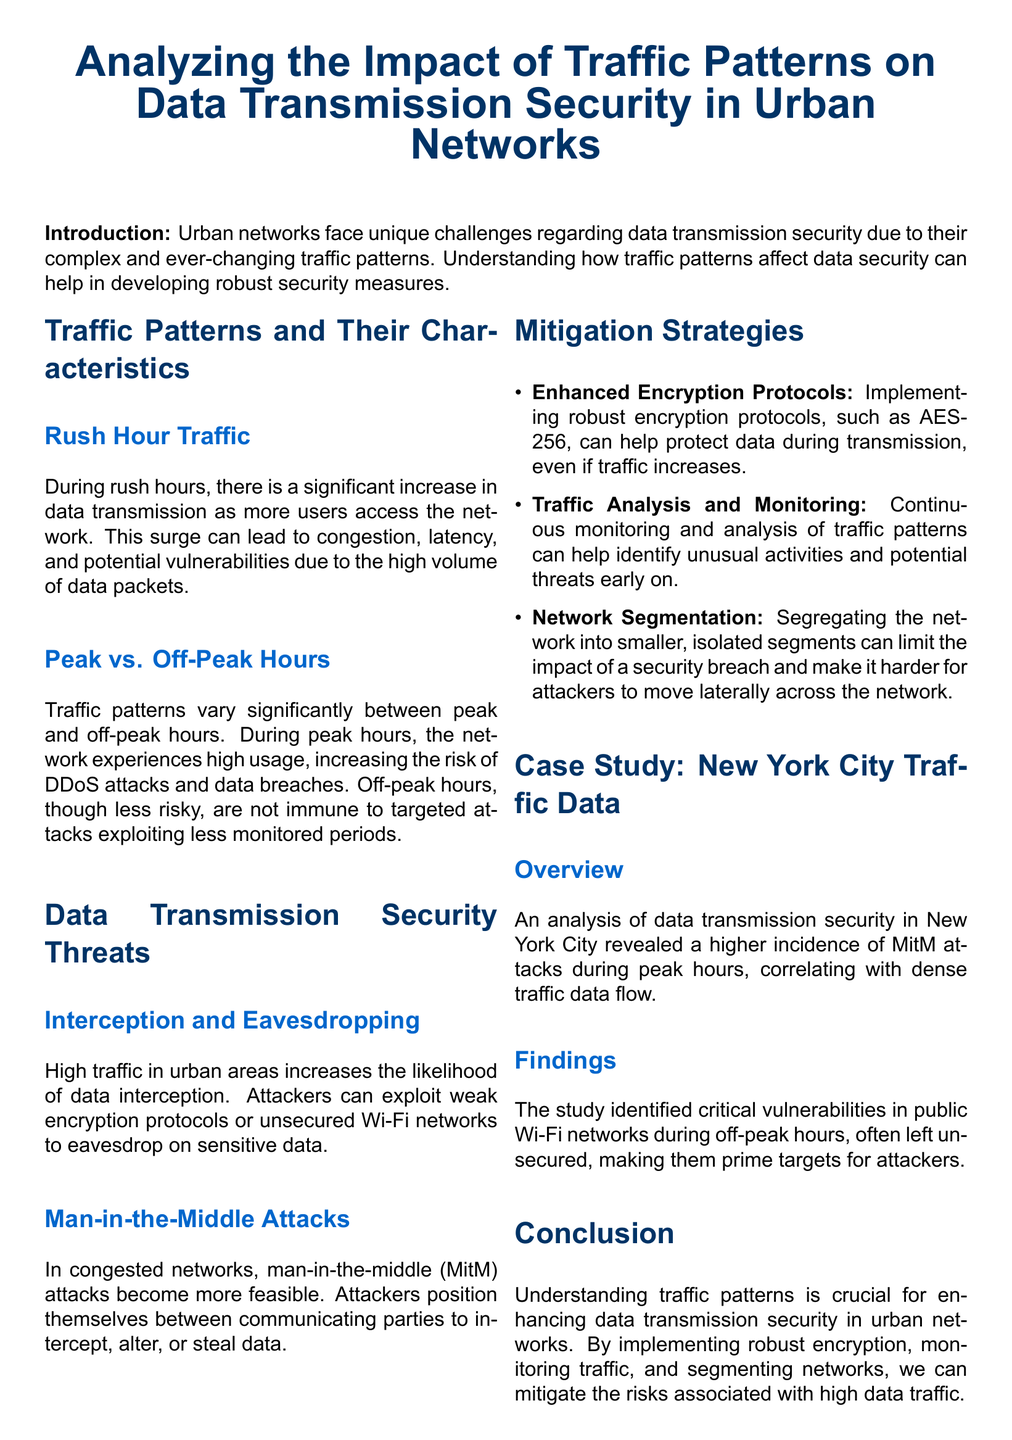What is the main topic of the document? The main topic of the document is analyzing the security of data transmission in the context of urban traffic patterns.
Answer: Analyzing the Impact of Traffic Patterns on Data Transmission Security in Urban Networks What are the two types of hours mentioned in relation to traffic patterns? The document highlights the differences between peak and off-peak hours.
Answer: Peak and Off-Peak Hours What type of attack increases during high traffic in urban areas? The document states that man-in-the-middle attacks become more feasible in congested networks.
Answer: Man-in-the-Middle Attacks What encryption protocol is recommended in the mitigation strategies? The document mentions implementing AES-256 as a robust encryption protocol.
Answer: AES-256 Which city is analyzed in the case study? The case study focuses on New York City and its traffic data analysis regarding data transmission security.
Answer: New York City What is a specific threat mentioned that occurs during rush hour? High traffic during rush hour increases the likelihood of data interception and eavesdropping.
Answer: Interception and Eavesdropping How does traffic analysis help in securing data transmission? Continuous monitoring of traffic patterns can identify unusual activities and potential threats.
Answer: Identify unusual activities What does the document suggest to limit the impact of a security breach? The document recommends network segmentation as a strategy to limit breach impact.
Answer: Network Segmentation What was a critical vulnerability found during the case study analysis? The study identified vulnerabilities in public Wi-Fi networks during off-peak hours, often left unsecured.
Answer: Public Wi-Fi networks left unsecured 